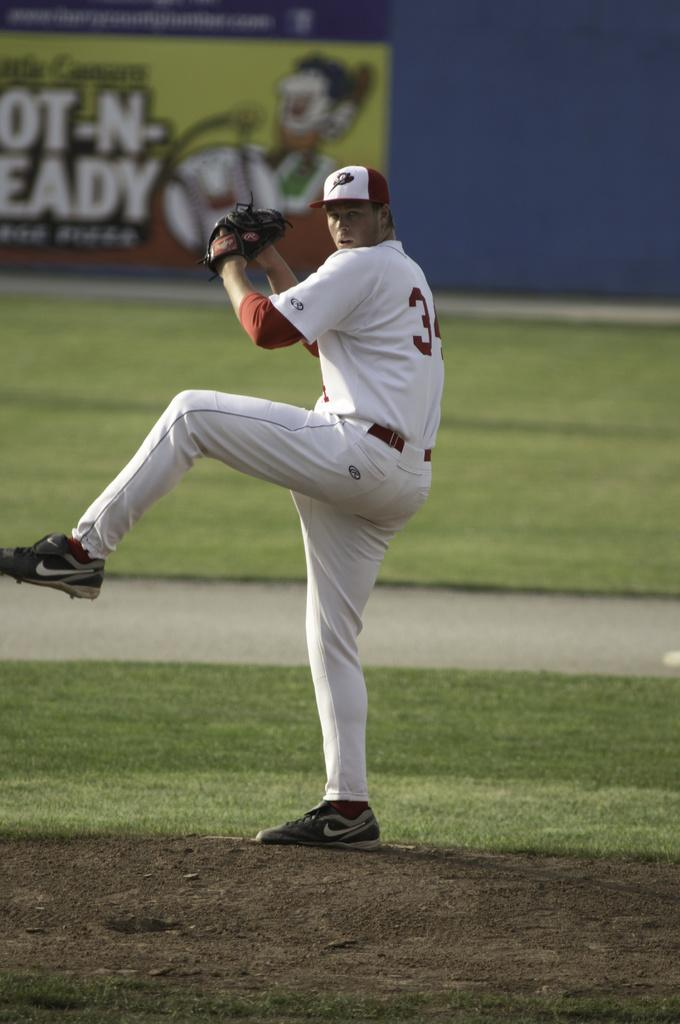<image>
Render a clear and concise summary of the photo. A Little Caesar's ad can be seen behind a baseball player. 